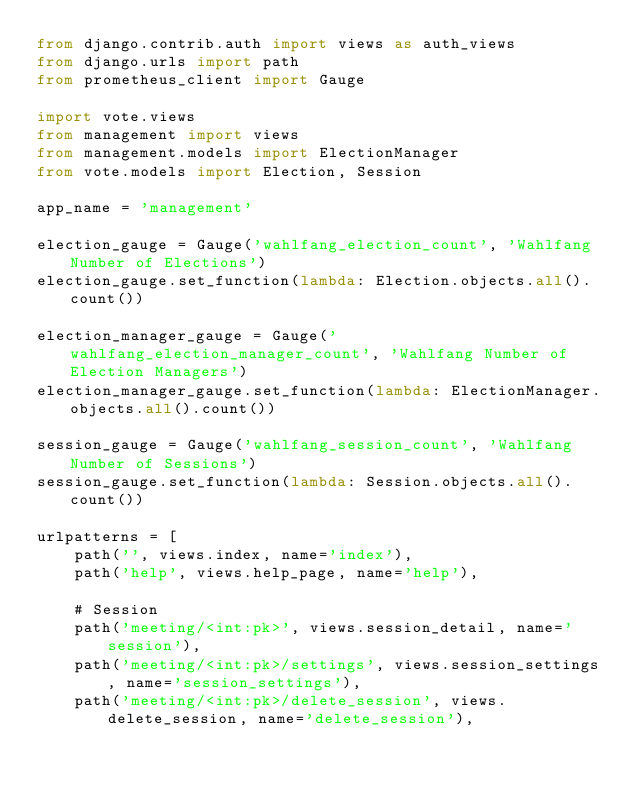<code> <loc_0><loc_0><loc_500><loc_500><_Python_>from django.contrib.auth import views as auth_views
from django.urls import path
from prometheus_client import Gauge

import vote.views
from management import views
from management.models import ElectionManager
from vote.models import Election, Session

app_name = 'management'

election_gauge = Gauge('wahlfang_election_count', 'Wahlfang Number of Elections')
election_gauge.set_function(lambda: Election.objects.all().count())

election_manager_gauge = Gauge('wahlfang_election_manager_count', 'Wahlfang Number of Election Managers')
election_manager_gauge.set_function(lambda: ElectionManager.objects.all().count())

session_gauge = Gauge('wahlfang_session_count', 'Wahlfang Number of Sessions')
session_gauge.set_function(lambda: Session.objects.all().count())

urlpatterns = [
    path('', views.index, name='index'),
    path('help', views.help_page, name='help'),

    # Session
    path('meeting/<int:pk>', views.session_detail, name='session'),
    path('meeting/<int:pk>/settings', views.session_settings, name='session_settings'),
    path('meeting/<int:pk>/delete_session', views.delete_session, name='delete_session'),</code> 